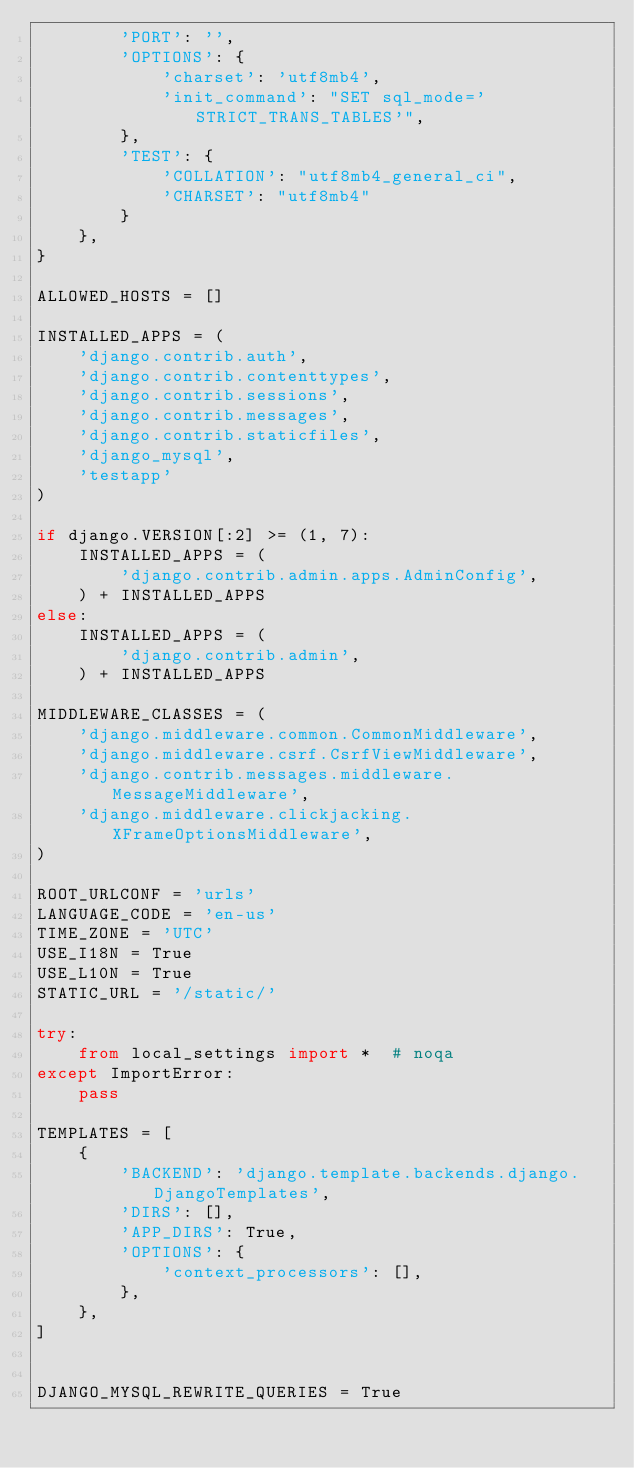Convert code to text. <code><loc_0><loc_0><loc_500><loc_500><_Python_>        'PORT': '',
        'OPTIONS': {
            'charset': 'utf8mb4',
            'init_command': "SET sql_mode='STRICT_TRANS_TABLES'",
        },
        'TEST': {
            'COLLATION': "utf8mb4_general_ci",
            'CHARSET': "utf8mb4"
        }
    },
}

ALLOWED_HOSTS = []

INSTALLED_APPS = (
    'django.contrib.auth',
    'django.contrib.contenttypes',
    'django.contrib.sessions',
    'django.contrib.messages',
    'django.contrib.staticfiles',
    'django_mysql',
    'testapp'
)

if django.VERSION[:2] >= (1, 7):
    INSTALLED_APPS = (
        'django.contrib.admin.apps.AdminConfig',
    ) + INSTALLED_APPS
else:
    INSTALLED_APPS = (
        'django.contrib.admin',
    ) + INSTALLED_APPS

MIDDLEWARE_CLASSES = (
    'django.middleware.common.CommonMiddleware',
    'django.middleware.csrf.CsrfViewMiddleware',
    'django.contrib.messages.middleware.MessageMiddleware',
    'django.middleware.clickjacking.XFrameOptionsMiddleware',
)

ROOT_URLCONF = 'urls'
LANGUAGE_CODE = 'en-us'
TIME_ZONE = 'UTC'
USE_I18N = True
USE_L10N = True
STATIC_URL = '/static/'

try:
    from local_settings import *  # noqa
except ImportError:
    pass

TEMPLATES = [
    {
        'BACKEND': 'django.template.backends.django.DjangoTemplates',
        'DIRS': [],
        'APP_DIRS': True,
        'OPTIONS': {
            'context_processors': [],
        },
    },
]


DJANGO_MYSQL_REWRITE_QUERIES = True
</code> 